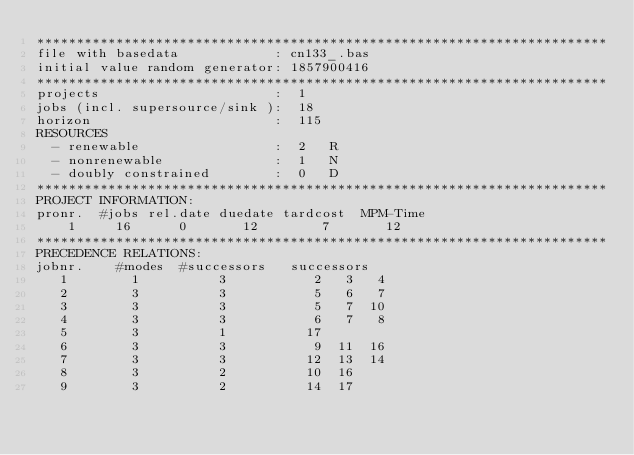Convert code to text. <code><loc_0><loc_0><loc_500><loc_500><_ObjectiveC_>************************************************************************
file with basedata            : cn133_.bas
initial value random generator: 1857900416
************************************************************************
projects                      :  1
jobs (incl. supersource/sink ):  18
horizon                       :  115
RESOURCES
  - renewable                 :  2   R
  - nonrenewable              :  1   N
  - doubly constrained        :  0   D
************************************************************************
PROJECT INFORMATION:
pronr.  #jobs rel.date duedate tardcost  MPM-Time
    1     16      0       12        7       12
************************************************************************
PRECEDENCE RELATIONS:
jobnr.    #modes  #successors   successors
   1        1          3           2   3   4
   2        3          3           5   6   7
   3        3          3           5   7  10
   4        3          3           6   7   8
   5        3          1          17
   6        3          3           9  11  16
   7        3          3          12  13  14
   8        3          2          10  16
   9        3          2          14  17</code> 